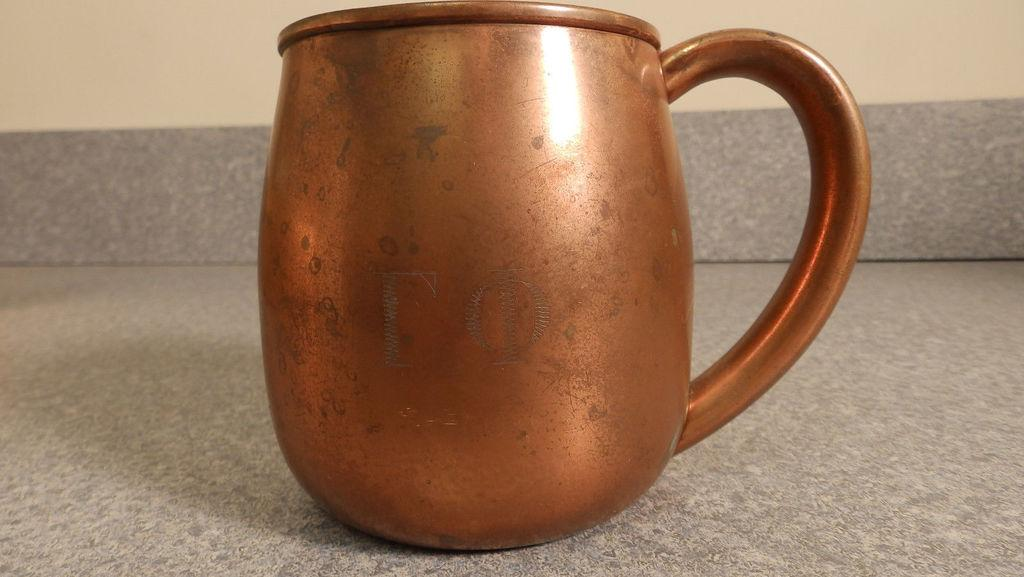What is the main object in the center of the image? There is a cup in the center of the image. What can be seen behind the cup in the image? There is a wall in the background of the image. What is visible at the bottom of the image? There is a floor visible at the bottom of the image. Is there a woman standing on a level surface in the image? There is no woman present in the image, so it cannot be determined if she is standing on a level surface. 